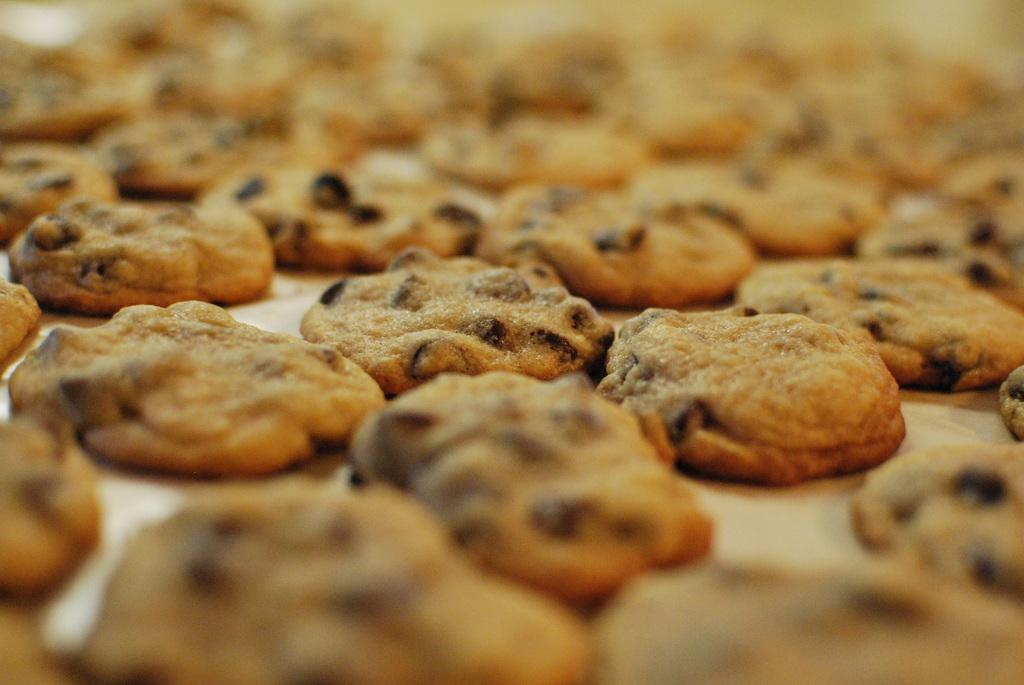What type of cookies can be seen in the image? There are brown color cookies in the image. Can you describe the clarity of the image? The image is blurry from the background. What type of soap is being used to clean the cabbage in the image? There is no soap or cabbage present in the image; it only features brown color cookies. What is the income of the person who baked the cookies in the image? There is no information about the income of the person who baked the cookies in the image. 